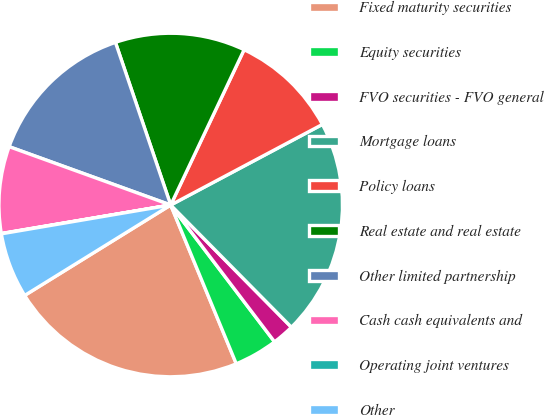Convert chart. <chart><loc_0><loc_0><loc_500><loc_500><pie_chart><fcel>Fixed maturity securities<fcel>Equity securities<fcel>FVO securities - FVO general<fcel>Mortgage loans<fcel>Policy loans<fcel>Real estate and real estate<fcel>Other limited partnership<fcel>Cash cash equivalents and<fcel>Operating joint ventures<fcel>Other<nl><fcel>22.41%<fcel>4.1%<fcel>2.07%<fcel>20.37%<fcel>10.2%<fcel>12.24%<fcel>14.27%<fcel>8.17%<fcel>0.03%<fcel>6.14%<nl></chart> 